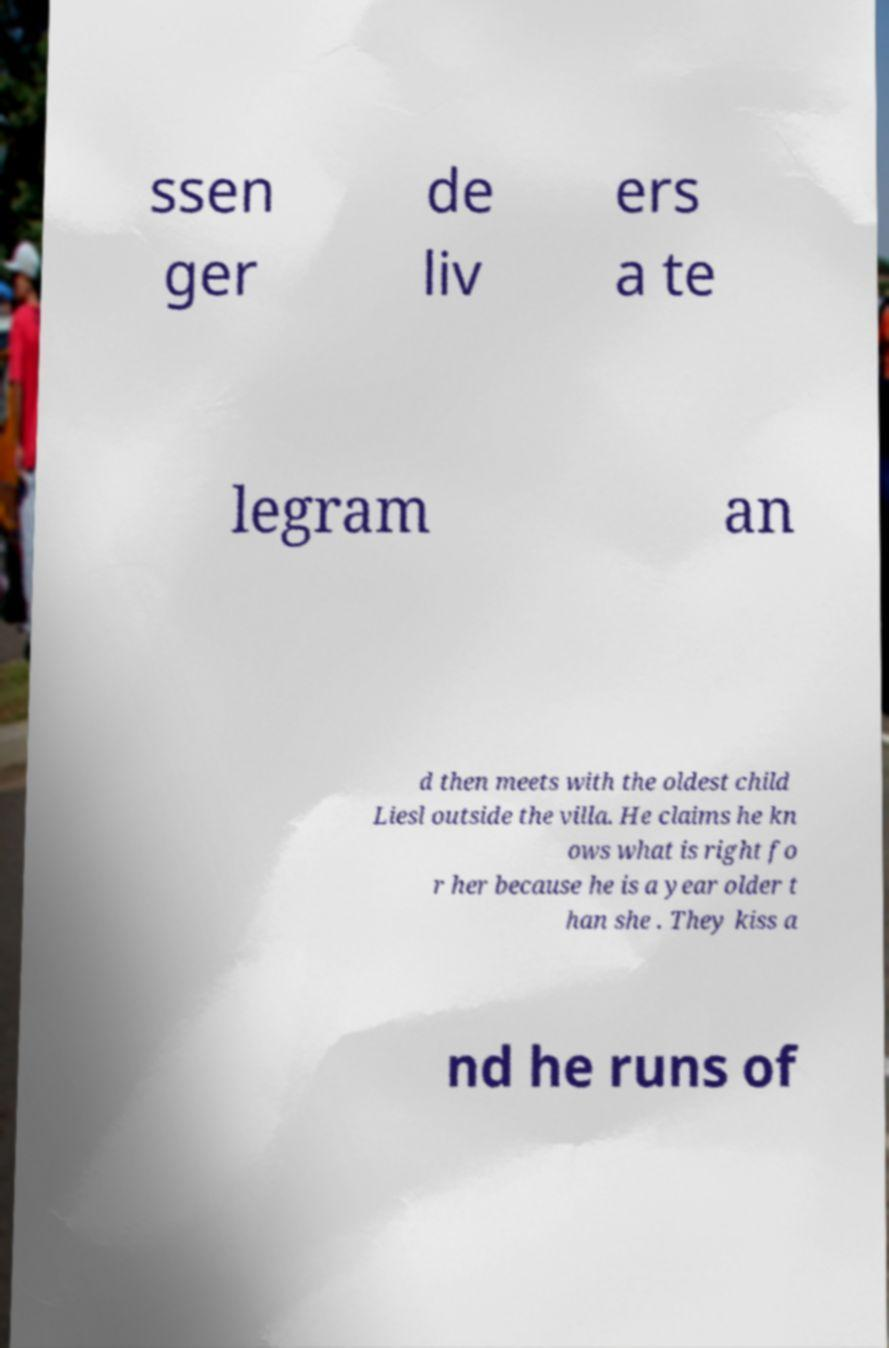Can you accurately transcribe the text from the provided image for me? ssen ger de liv ers a te legram an d then meets with the oldest child Liesl outside the villa. He claims he kn ows what is right fo r her because he is a year older t han she . They kiss a nd he runs of 